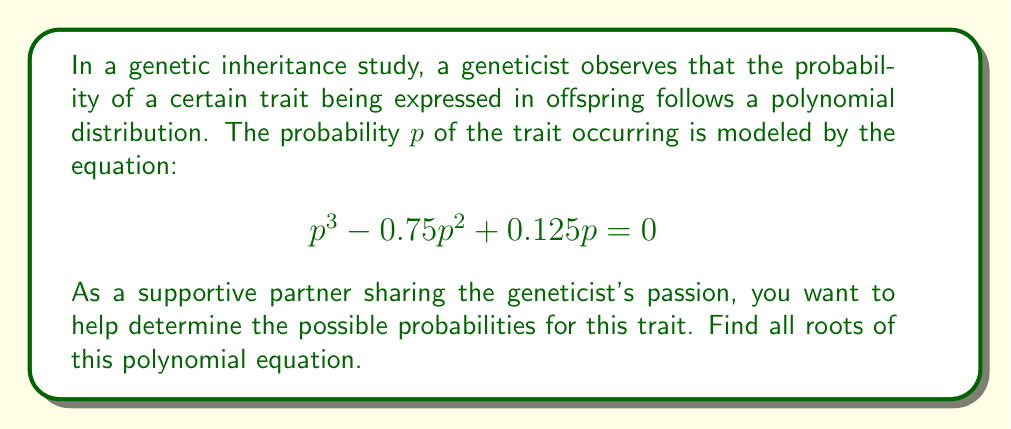Can you answer this question? Let's solve this step-by-step:

1) First, we can factor out $p$ from all terms:
   $$p(p^2 - 0.75p + 0.125) = 0$$

2) By the zero product property, either $p = 0$ or $p^2 - 0.75p + 0.125 = 0$

3) We already have one root: $p = 0$

4) For the quadratic equation $p^2 - 0.75p + 0.125 = 0$, we can use the quadratic formula:
   $$p = \frac{-b \pm \sqrt{b^2 - 4ac}}{2a}$$
   where $a = 1$, $b = -0.75$, and $c = 0.125$

5) Substituting these values:
   $$p = \frac{0.75 \pm \sqrt{(-0.75)^2 - 4(1)(0.125)}}{2(1)}$$

6) Simplifying under the square root:
   $$p = \frac{0.75 \pm \sqrt{0.5625 - 0.5}}{2} = \frac{0.75 \pm \sqrt{0.0625}}{2}$$

7) Simplifying further:
   $$p = \frac{0.75 \pm 0.25}{2}$$

8) This gives us two more roots:
   $$p = \frac{0.75 + 0.25}{2} = \frac{1}{2} = 0.5$$
   $$p = \frac{0.75 - 0.25}{2} = \frac{1}{4} = 0.25$$

Therefore, the three roots of the polynomial are 0, 0.25, and 0.5.
Answer: $p = 0$, $p = 0.25$, $p = 0.5$ 